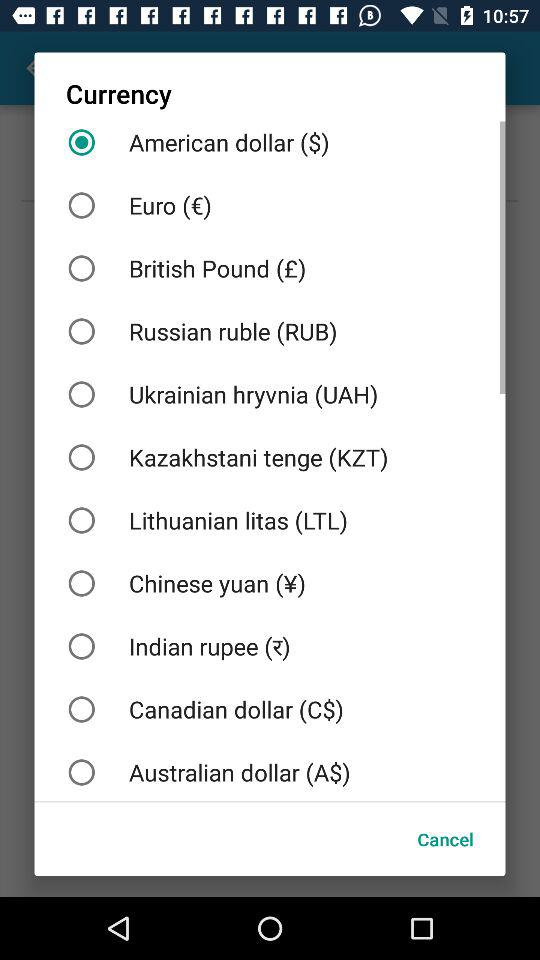Which is the selected currency? The selected currency is the American dollar ($). 